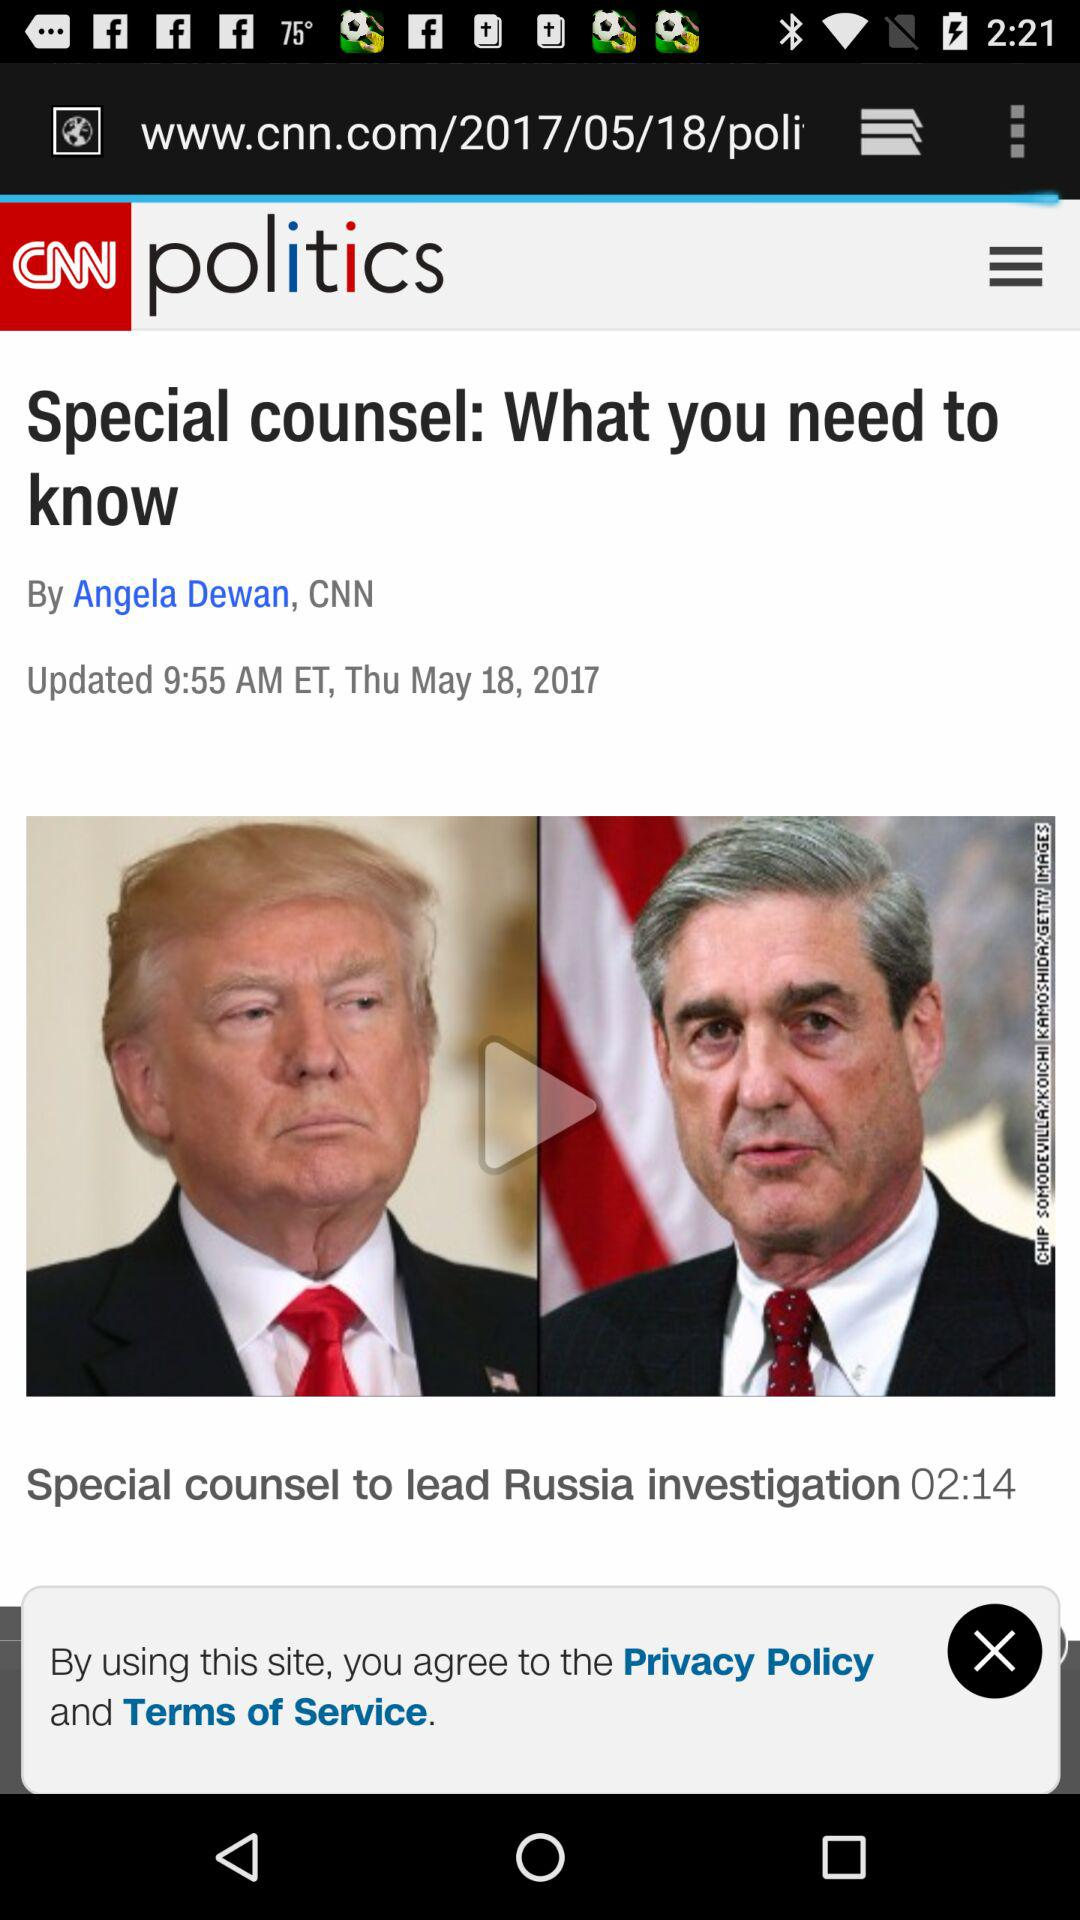What is the updated date of the article? The updated date of the article is Thursday, May 18, 2017. 